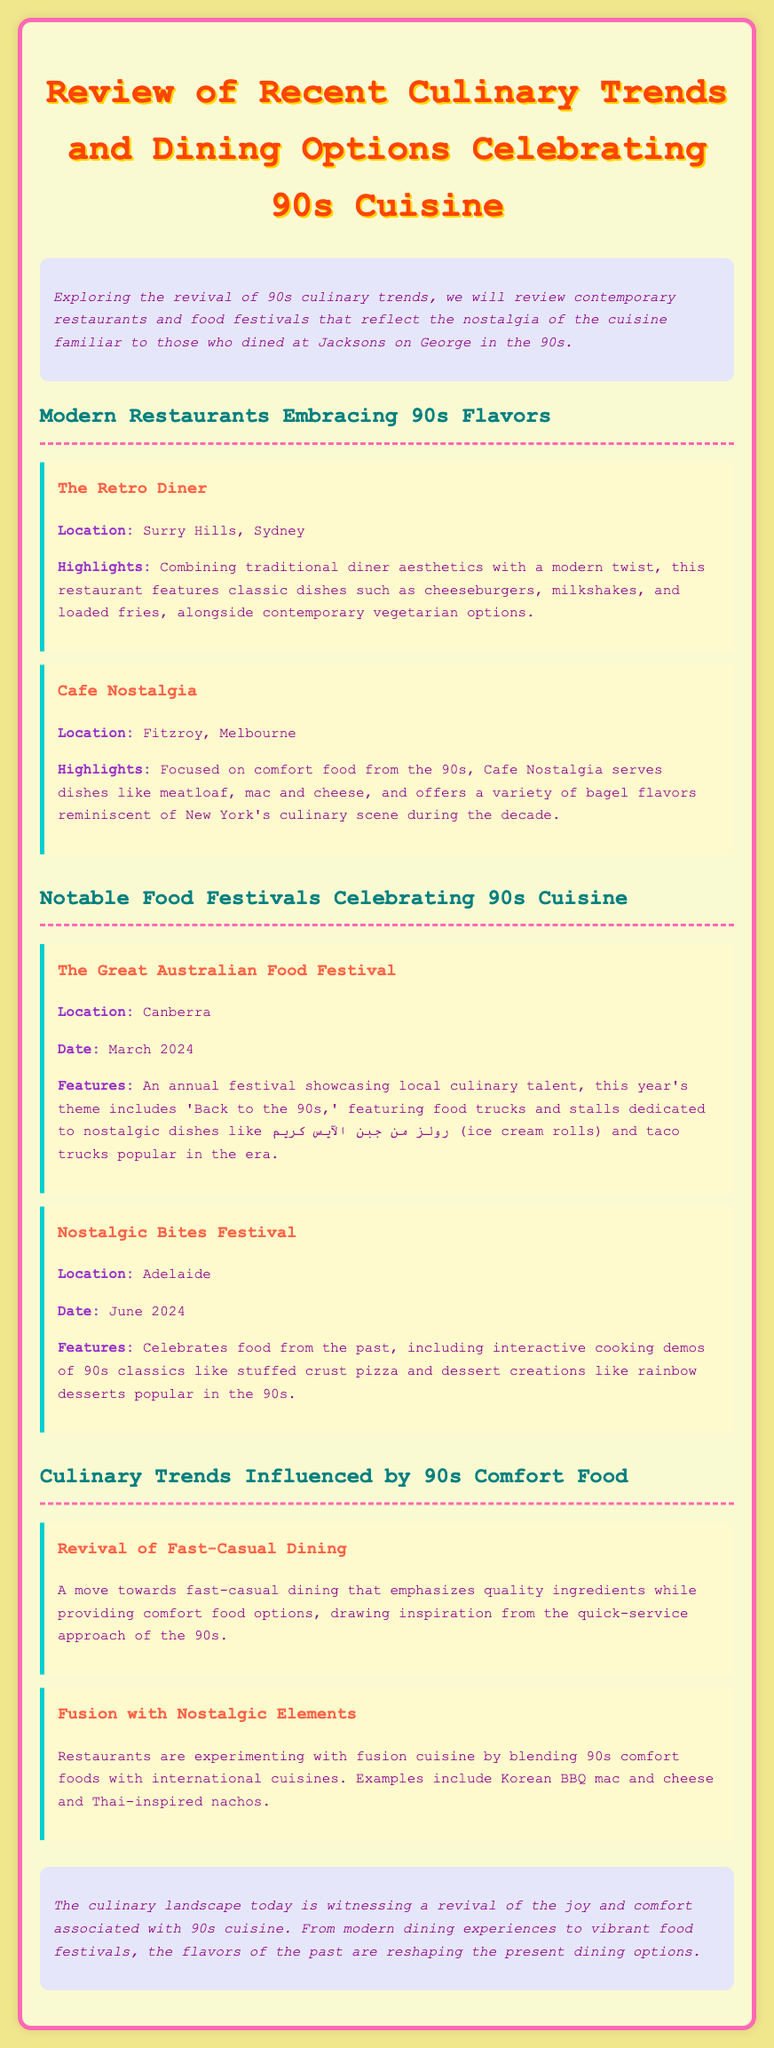what is the name of a restaurant in Surry Hills that features classic dishes? The document lists "The Retro Diner" as a restaurant in Surry Hills that features classic dishes.
Answer: The Retro Diner what is the focus of Cafe Nostalgia in Fitzroy? Cafe Nostalgia focuses on comfort food from the 90s, serving dishes like meatloaf and mac and cheese.
Answer: Comfort food when is The Great Australian Food Festival scheduled to take place? The date of The Great Australian Food Festival is mentioned as March 2024.
Answer: March 2024 what is a featured dish at the Nostalgic Bites Festival? The festival includes interactive cooking demos of stuffed crust pizza as a featured dish.
Answer: Stuffed crust pizza what culinary trend emphasizes the use of quality ingredients while providing comfort food options? The document describes a revival of fast-casual dining that emphasizes quality ingredients while providing comfort food.
Answer: Fast-casual dining what type of cuisine are restaurants experimenting with in fusion dishes? Restaurants are experimenting with blending 90s comfort foods with international cuisines in their fusion dishes.
Answer: International cuisines which city hosts the Nostalgic Bites Festival? The document identifies Adelaide as the location of the Nostalgic Bites Festival.
Answer: Adelaide what is the theme of this year's Great Australian Food Festival? The theme of this year's festival is 'Back to the 90s.'
Answer: Back to the 90s 